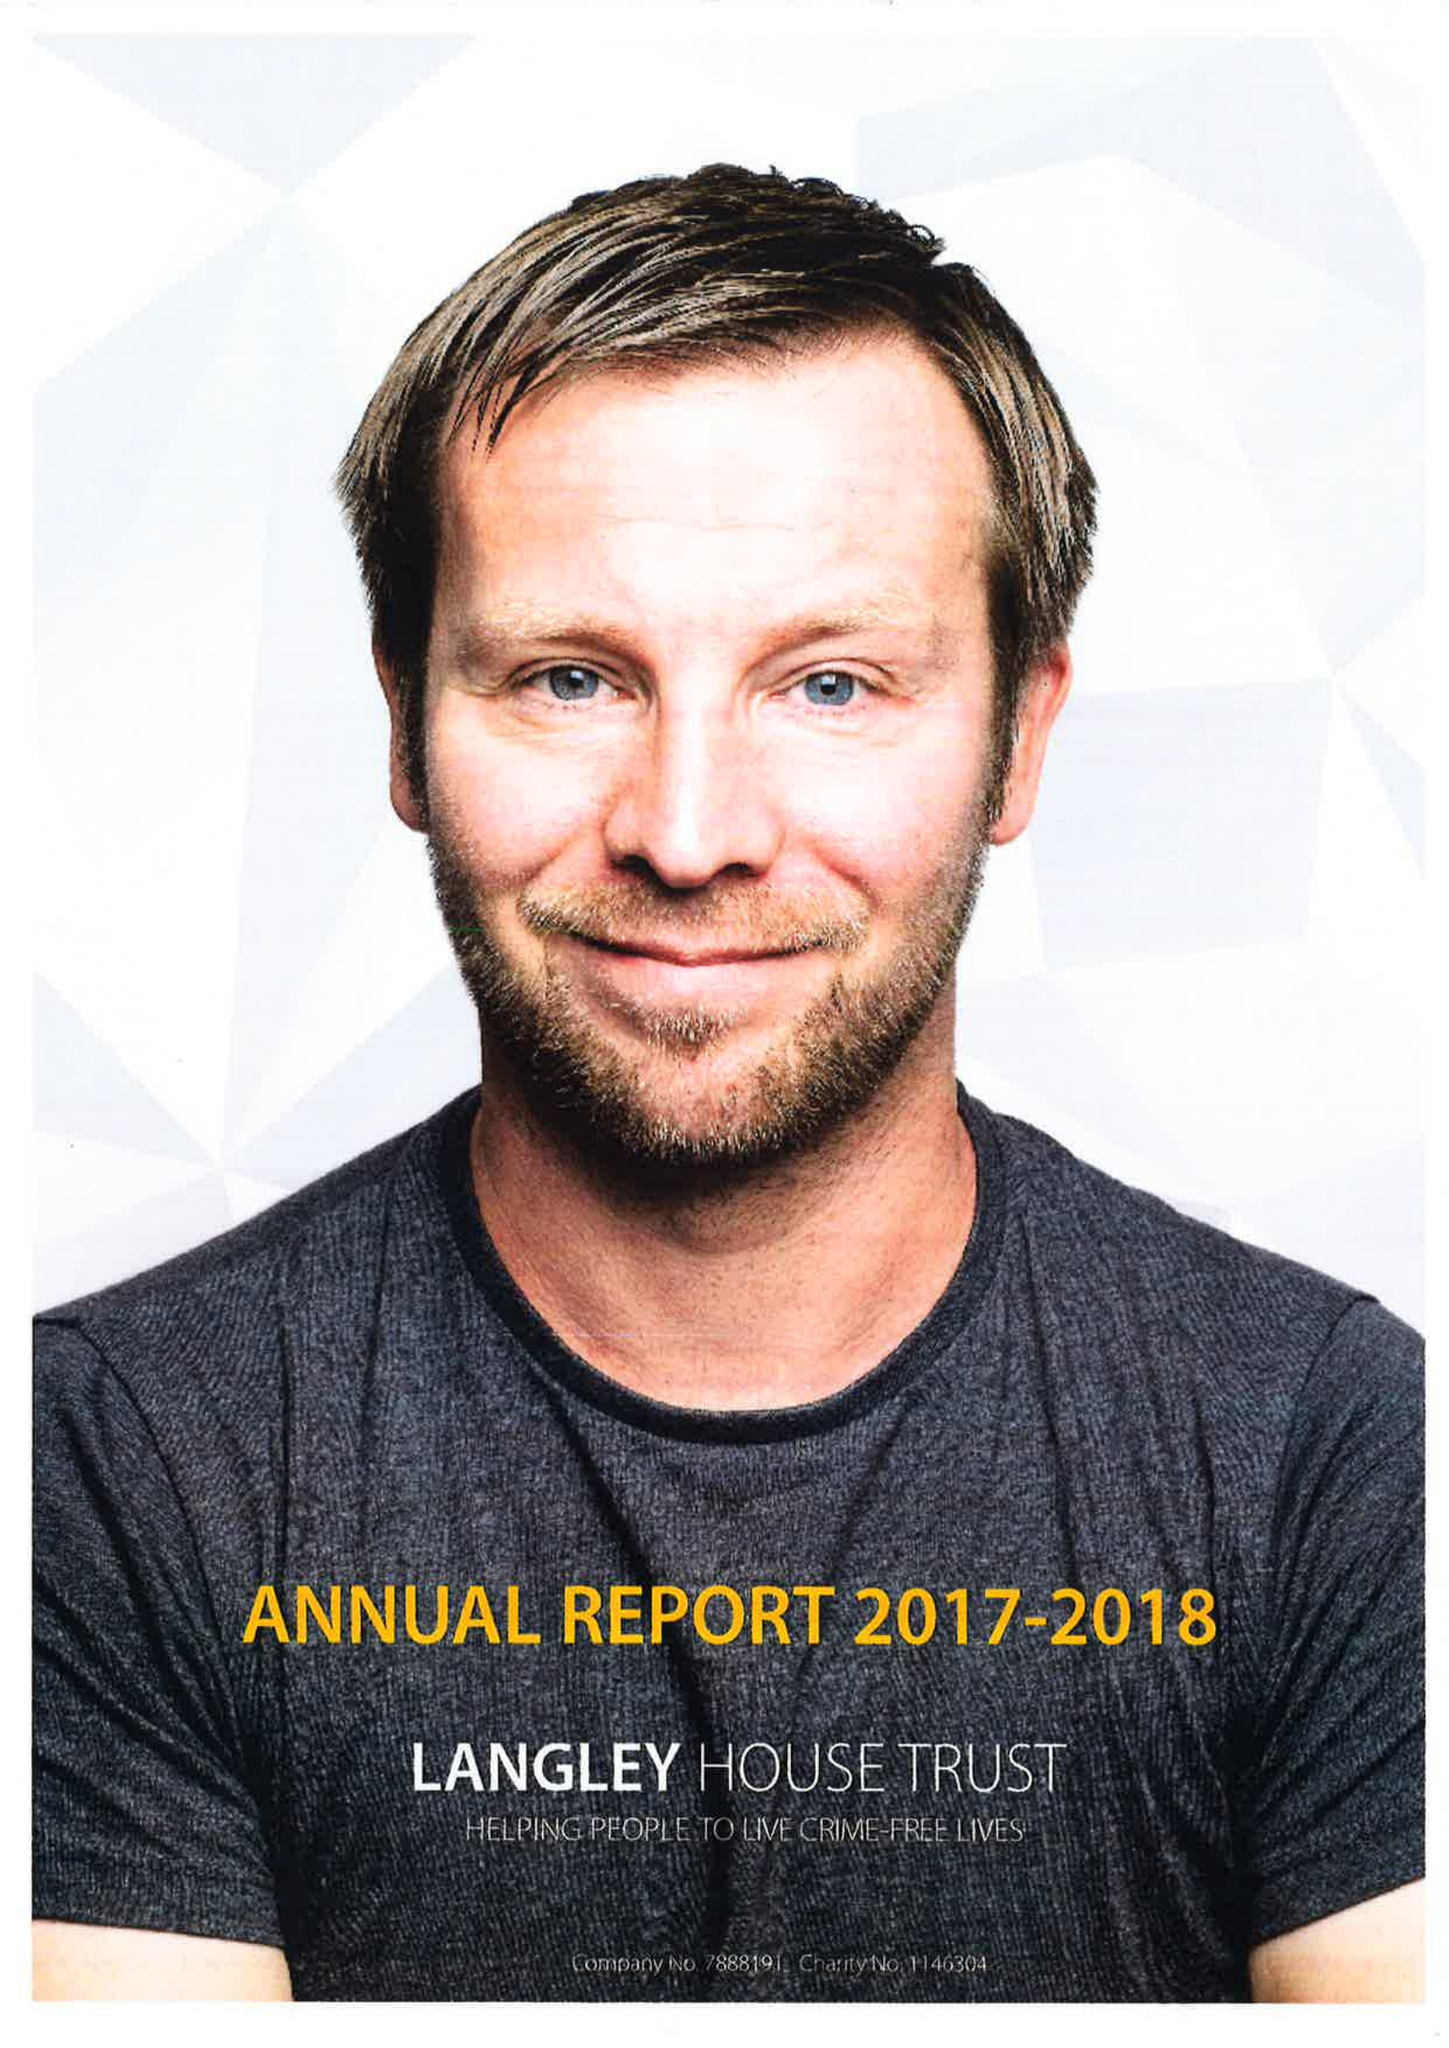What is the value for the charity_number?
Answer the question using a single word or phrase. 1146304 